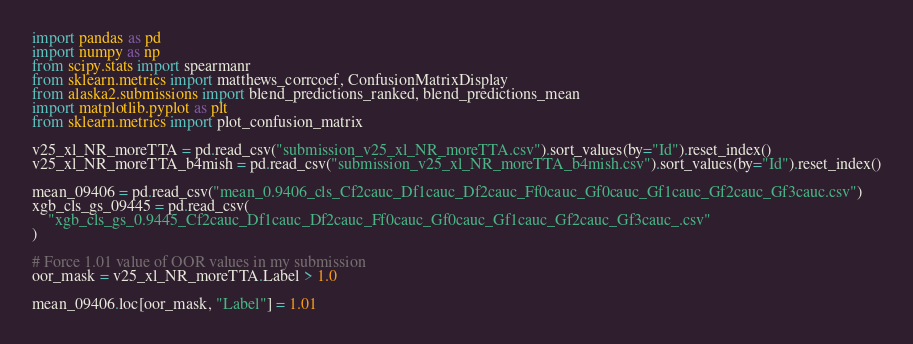<code> <loc_0><loc_0><loc_500><loc_500><_Python_>import pandas as pd
import numpy as np
from scipy.stats import spearmanr
from sklearn.metrics import matthews_corrcoef, ConfusionMatrixDisplay
from alaska2.submissions import blend_predictions_ranked, blend_predictions_mean
import matplotlib.pyplot as plt
from sklearn.metrics import plot_confusion_matrix

v25_xl_NR_moreTTA = pd.read_csv("submission_v25_xl_NR_moreTTA.csv").sort_values(by="Id").reset_index()
v25_xl_NR_moreTTA_b4mish = pd.read_csv("submission_v25_xl_NR_moreTTA_b4mish.csv").sort_values(by="Id").reset_index()

mean_09406 = pd.read_csv("mean_0.9406_cls_Cf2cauc_Df1cauc_Df2cauc_Ff0cauc_Gf0cauc_Gf1cauc_Gf2cauc_Gf3cauc.csv")
xgb_cls_gs_09445 = pd.read_csv(
    "xgb_cls_gs_0.9445_Cf2cauc_Df1cauc_Df2cauc_Ff0cauc_Gf0cauc_Gf1cauc_Gf2cauc_Gf3cauc_.csv"
)

# Force 1.01 value of OOR values in my submission
oor_mask = v25_xl_NR_moreTTA.Label > 1.0

mean_09406.loc[oor_mask, "Label"] = 1.01</code> 